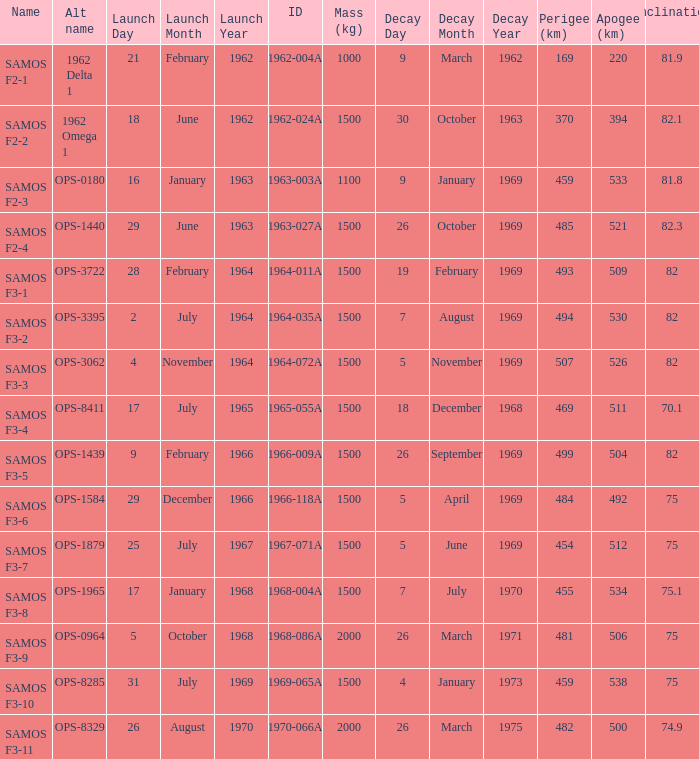What is the maximum apogee for samos f3-3? 526.0. 